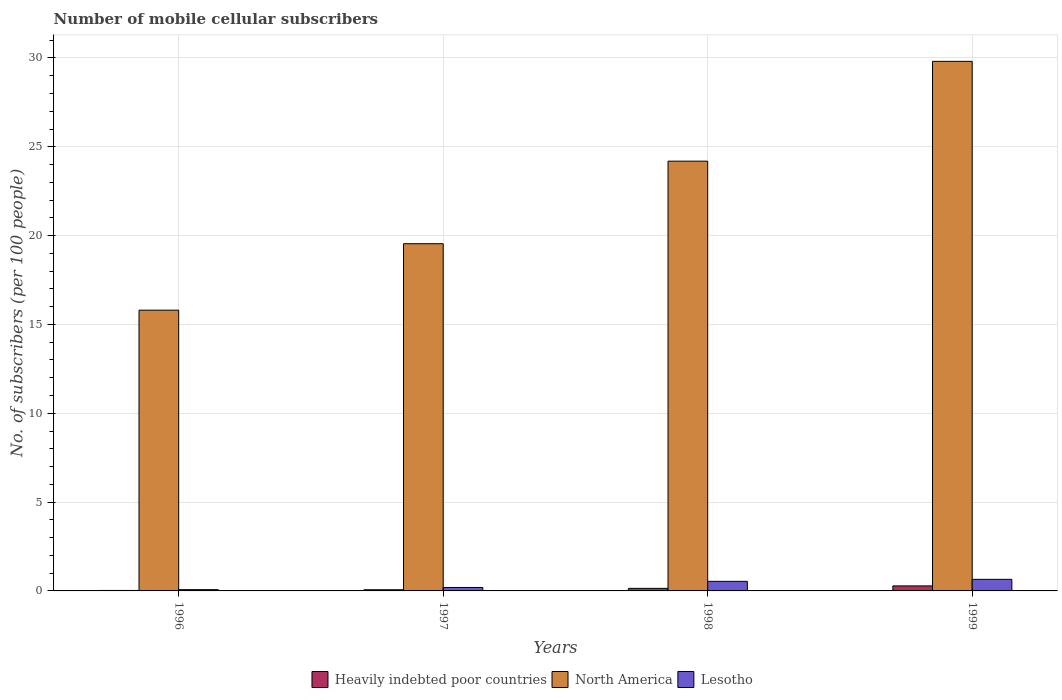How many different coloured bars are there?
Ensure brevity in your answer.  3. Are the number of bars on each tick of the X-axis equal?
Make the answer very short. Yes. How many bars are there on the 3rd tick from the left?
Give a very brief answer. 3. What is the label of the 3rd group of bars from the left?
Give a very brief answer. 1998. In how many cases, is the number of bars for a given year not equal to the number of legend labels?
Your answer should be very brief. 0. What is the number of mobile cellular subscribers in Heavily indebted poor countries in 1998?
Offer a very short reply. 0.14. Across all years, what is the maximum number of mobile cellular subscribers in North America?
Ensure brevity in your answer.  29.81. Across all years, what is the minimum number of mobile cellular subscribers in North America?
Offer a very short reply. 15.8. In which year was the number of mobile cellular subscribers in North America minimum?
Ensure brevity in your answer.  1996. What is the total number of mobile cellular subscribers in Heavily indebted poor countries in the graph?
Your answer should be very brief. 0.52. What is the difference between the number of mobile cellular subscribers in Lesotho in 1996 and that in 1999?
Your response must be concise. -0.58. What is the difference between the number of mobile cellular subscribers in Lesotho in 1999 and the number of mobile cellular subscribers in Heavily indebted poor countries in 1996?
Offer a very short reply. 0.63. What is the average number of mobile cellular subscribers in Heavily indebted poor countries per year?
Provide a succinct answer. 0.13. In the year 1999, what is the difference between the number of mobile cellular subscribers in North America and number of mobile cellular subscribers in Heavily indebted poor countries?
Ensure brevity in your answer.  29.53. In how many years, is the number of mobile cellular subscribers in Lesotho greater than 25?
Offer a very short reply. 0. What is the ratio of the number of mobile cellular subscribers in Lesotho in 1997 to that in 1999?
Your answer should be compact. 0.3. Is the difference between the number of mobile cellular subscribers in North America in 1997 and 1998 greater than the difference between the number of mobile cellular subscribers in Heavily indebted poor countries in 1997 and 1998?
Your response must be concise. No. What is the difference between the highest and the second highest number of mobile cellular subscribers in North America?
Keep it short and to the point. 5.62. What is the difference between the highest and the lowest number of mobile cellular subscribers in Lesotho?
Offer a very short reply. 0.58. In how many years, is the number of mobile cellular subscribers in Heavily indebted poor countries greater than the average number of mobile cellular subscribers in Heavily indebted poor countries taken over all years?
Offer a very short reply. 2. Is the sum of the number of mobile cellular subscribers in Heavily indebted poor countries in 1996 and 1997 greater than the maximum number of mobile cellular subscribers in Lesotho across all years?
Your answer should be very brief. No. What does the 3rd bar from the left in 1999 represents?
Make the answer very short. Lesotho. What does the 1st bar from the right in 1999 represents?
Provide a succinct answer. Lesotho. Is it the case that in every year, the sum of the number of mobile cellular subscribers in Lesotho and number of mobile cellular subscribers in Heavily indebted poor countries is greater than the number of mobile cellular subscribers in North America?
Provide a short and direct response. No. How many bars are there?
Make the answer very short. 12. Does the graph contain any zero values?
Ensure brevity in your answer.  No. Does the graph contain grids?
Offer a terse response. Yes. Where does the legend appear in the graph?
Offer a terse response. Bottom center. How many legend labels are there?
Offer a terse response. 3. What is the title of the graph?
Offer a very short reply. Number of mobile cellular subscribers. What is the label or title of the Y-axis?
Your response must be concise. No. of subscribers (per 100 people). What is the No. of subscribers (per 100 people) of Heavily indebted poor countries in 1996?
Keep it short and to the point. 0.03. What is the No. of subscribers (per 100 people) of North America in 1996?
Provide a short and direct response. 15.8. What is the No. of subscribers (per 100 people) in Lesotho in 1996?
Provide a short and direct response. 0.07. What is the No. of subscribers (per 100 people) of Heavily indebted poor countries in 1997?
Your response must be concise. 0.07. What is the No. of subscribers (per 100 people) in North America in 1997?
Provide a succinct answer. 19.54. What is the No. of subscribers (per 100 people) of Lesotho in 1997?
Provide a short and direct response. 0.19. What is the No. of subscribers (per 100 people) of Heavily indebted poor countries in 1998?
Keep it short and to the point. 0.14. What is the No. of subscribers (per 100 people) of North America in 1998?
Make the answer very short. 24.19. What is the No. of subscribers (per 100 people) in Lesotho in 1998?
Provide a short and direct response. 0.54. What is the No. of subscribers (per 100 people) of Heavily indebted poor countries in 1999?
Your answer should be compact. 0.28. What is the No. of subscribers (per 100 people) of North America in 1999?
Your answer should be very brief. 29.81. What is the No. of subscribers (per 100 people) in Lesotho in 1999?
Offer a very short reply. 0.65. Across all years, what is the maximum No. of subscribers (per 100 people) in Heavily indebted poor countries?
Give a very brief answer. 0.28. Across all years, what is the maximum No. of subscribers (per 100 people) in North America?
Give a very brief answer. 29.81. Across all years, what is the maximum No. of subscribers (per 100 people) of Lesotho?
Ensure brevity in your answer.  0.65. Across all years, what is the minimum No. of subscribers (per 100 people) in Heavily indebted poor countries?
Your answer should be compact. 0.03. Across all years, what is the minimum No. of subscribers (per 100 people) of North America?
Keep it short and to the point. 15.8. Across all years, what is the minimum No. of subscribers (per 100 people) in Lesotho?
Give a very brief answer. 0.07. What is the total No. of subscribers (per 100 people) in Heavily indebted poor countries in the graph?
Offer a very short reply. 0.52. What is the total No. of subscribers (per 100 people) of North America in the graph?
Give a very brief answer. 89.35. What is the total No. of subscribers (per 100 people) in Lesotho in the graph?
Your answer should be compact. 1.46. What is the difference between the No. of subscribers (per 100 people) of Heavily indebted poor countries in 1996 and that in 1997?
Ensure brevity in your answer.  -0.04. What is the difference between the No. of subscribers (per 100 people) in North America in 1996 and that in 1997?
Ensure brevity in your answer.  -3.74. What is the difference between the No. of subscribers (per 100 people) of Lesotho in 1996 and that in 1997?
Your response must be concise. -0.12. What is the difference between the No. of subscribers (per 100 people) of Heavily indebted poor countries in 1996 and that in 1998?
Provide a short and direct response. -0.12. What is the difference between the No. of subscribers (per 100 people) of North America in 1996 and that in 1998?
Your answer should be compact. -8.39. What is the difference between the No. of subscribers (per 100 people) of Lesotho in 1996 and that in 1998?
Ensure brevity in your answer.  -0.47. What is the difference between the No. of subscribers (per 100 people) in Heavily indebted poor countries in 1996 and that in 1999?
Provide a succinct answer. -0.26. What is the difference between the No. of subscribers (per 100 people) of North America in 1996 and that in 1999?
Keep it short and to the point. -14. What is the difference between the No. of subscribers (per 100 people) of Lesotho in 1996 and that in 1999?
Your answer should be compact. -0.58. What is the difference between the No. of subscribers (per 100 people) in Heavily indebted poor countries in 1997 and that in 1998?
Provide a short and direct response. -0.08. What is the difference between the No. of subscribers (per 100 people) of North America in 1997 and that in 1998?
Your response must be concise. -4.65. What is the difference between the No. of subscribers (per 100 people) of Lesotho in 1997 and that in 1998?
Give a very brief answer. -0.35. What is the difference between the No. of subscribers (per 100 people) in Heavily indebted poor countries in 1997 and that in 1999?
Your response must be concise. -0.22. What is the difference between the No. of subscribers (per 100 people) in North America in 1997 and that in 1999?
Provide a succinct answer. -10.26. What is the difference between the No. of subscribers (per 100 people) in Lesotho in 1997 and that in 1999?
Give a very brief answer. -0.46. What is the difference between the No. of subscribers (per 100 people) of Heavily indebted poor countries in 1998 and that in 1999?
Keep it short and to the point. -0.14. What is the difference between the No. of subscribers (per 100 people) of North America in 1998 and that in 1999?
Your response must be concise. -5.62. What is the difference between the No. of subscribers (per 100 people) in Lesotho in 1998 and that in 1999?
Provide a succinct answer. -0.11. What is the difference between the No. of subscribers (per 100 people) in Heavily indebted poor countries in 1996 and the No. of subscribers (per 100 people) in North America in 1997?
Provide a succinct answer. -19.52. What is the difference between the No. of subscribers (per 100 people) in Heavily indebted poor countries in 1996 and the No. of subscribers (per 100 people) in Lesotho in 1997?
Offer a very short reply. -0.17. What is the difference between the No. of subscribers (per 100 people) in North America in 1996 and the No. of subscribers (per 100 people) in Lesotho in 1997?
Your response must be concise. 15.61. What is the difference between the No. of subscribers (per 100 people) of Heavily indebted poor countries in 1996 and the No. of subscribers (per 100 people) of North America in 1998?
Your response must be concise. -24.16. What is the difference between the No. of subscribers (per 100 people) in Heavily indebted poor countries in 1996 and the No. of subscribers (per 100 people) in Lesotho in 1998?
Your response must be concise. -0.51. What is the difference between the No. of subscribers (per 100 people) in North America in 1996 and the No. of subscribers (per 100 people) in Lesotho in 1998?
Ensure brevity in your answer.  15.26. What is the difference between the No. of subscribers (per 100 people) of Heavily indebted poor countries in 1996 and the No. of subscribers (per 100 people) of North America in 1999?
Your response must be concise. -29.78. What is the difference between the No. of subscribers (per 100 people) of Heavily indebted poor countries in 1996 and the No. of subscribers (per 100 people) of Lesotho in 1999?
Give a very brief answer. -0.63. What is the difference between the No. of subscribers (per 100 people) in North America in 1996 and the No. of subscribers (per 100 people) in Lesotho in 1999?
Your answer should be very brief. 15.15. What is the difference between the No. of subscribers (per 100 people) of Heavily indebted poor countries in 1997 and the No. of subscribers (per 100 people) of North America in 1998?
Offer a terse response. -24.12. What is the difference between the No. of subscribers (per 100 people) of Heavily indebted poor countries in 1997 and the No. of subscribers (per 100 people) of Lesotho in 1998?
Offer a very short reply. -0.47. What is the difference between the No. of subscribers (per 100 people) of North America in 1997 and the No. of subscribers (per 100 people) of Lesotho in 1998?
Offer a terse response. 19. What is the difference between the No. of subscribers (per 100 people) in Heavily indebted poor countries in 1997 and the No. of subscribers (per 100 people) in North America in 1999?
Provide a short and direct response. -29.74. What is the difference between the No. of subscribers (per 100 people) in Heavily indebted poor countries in 1997 and the No. of subscribers (per 100 people) in Lesotho in 1999?
Make the answer very short. -0.59. What is the difference between the No. of subscribers (per 100 people) in North America in 1997 and the No. of subscribers (per 100 people) in Lesotho in 1999?
Keep it short and to the point. 18.89. What is the difference between the No. of subscribers (per 100 people) of Heavily indebted poor countries in 1998 and the No. of subscribers (per 100 people) of North America in 1999?
Your response must be concise. -29.66. What is the difference between the No. of subscribers (per 100 people) of Heavily indebted poor countries in 1998 and the No. of subscribers (per 100 people) of Lesotho in 1999?
Give a very brief answer. -0.51. What is the difference between the No. of subscribers (per 100 people) of North America in 1998 and the No. of subscribers (per 100 people) of Lesotho in 1999?
Offer a terse response. 23.54. What is the average No. of subscribers (per 100 people) in Heavily indebted poor countries per year?
Provide a short and direct response. 0.13. What is the average No. of subscribers (per 100 people) in North America per year?
Offer a very short reply. 22.34. What is the average No. of subscribers (per 100 people) in Lesotho per year?
Offer a terse response. 0.36. In the year 1996, what is the difference between the No. of subscribers (per 100 people) of Heavily indebted poor countries and No. of subscribers (per 100 people) of North America?
Make the answer very short. -15.78. In the year 1996, what is the difference between the No. of subscribers (per 100 people) of Heavily indebted poor countries and No. of subscribers (per 100 people) of Lesotho?
Your response must be concise. -0.04. In the year 1996, what is the difference between the No. of subscribers (per 100 people) of North America and No. of subscribers (per 100 people) of Lesotho?
Provide a succinct answer. 15.73. In the year 1997, what is the difference between the No. of subscribers (per 100 people) in Heavily indebted poor countries and No. of subscribers (per 100 people) in North America?
Make the answer very short. -19.48. In the year 1997, what is the difference between the No. of subscribers (per 100 people) in Heavily indebted poor countries and No. of subscribers (per 100 people) in Lesotho?
Provide a succinct answer. -0.13. In the year 1997, what is the difference between the No. of subscribers (per 100 people) of North America and No. of subscribers (per 100 people) of Lesotho?
Give a very brief answer. 19.35. In the year 1998, what is the difference between the No. of subscribers (per 100 people) in Heavily indebted poor countries and No. of subscribers (per 100 people) in North America?
Your response must be concise. -24.05. In the year 1998, what is the difference between the No. of subscribers (per 100 people) of Heavily indebted poor countries and No. of subscribers (per 100 people) of Lesotho?
Provide a succinct answer. -0.4. In the year 1998, what is the difference between the No. of subscribers (per 100 people) in North America and No. of subscribers (per 100 people) in Lesotho?
Keep it short and to the point. 23.65. In the year 1999, what is the difference between the No. of subscribers (per 100 people) of Heavily indebted poor countries and No. of subscribers (per 100 people) of North America?
Your response must be concise. -29.53. In the year 1999, what is the difference between the No. of subscribers (per 100 people) in Heavily indebted poor countries and No. of subscribers (per 100 people) in Lesotho?
Give a very brief answer. -0.37. In the year 1999, what is the difference between the No. of subscribers (per 100 people) of North America and No. of subscribers (per 100 people) of Lesotho?
Keep it short and to the point. 29.16. What is the ratio of the No. of subscribers (per 100 people) in Heavily indebted poor countries in 1996 to that in 1997?
Your answer should be compact. 0.41. What is the ratio of the No. of subscribers (per 100 people) in North America in 1996 to that in 1997?
Provide a succinct answer. 0.81. What is the ratio of the No. of subscribers (per 100 people) of Lesotho in 1996 to that in 1997?
Offer a terse response. 0.37. What is the ratio of the No. of subscribers (per 100 people) of Heavily indebted poor countries in 1996 to that in 1998?
Your response must be concise. 0.19. What is the ratio of the No. of subscribers (per 100 people) in North America in 1996 to that in 1998?
Ensure brevity in your answer.  0.65. What is the ratio of the No. of subscribers (per 100 people) in Lesotho in 1996 to that in 1998?
Offer a terse response. 0.13. What is the ratio of the No. of subscribers (per 100 people) of Heavily indebted poor countries in 1996 to that in 1999?
Give a very brief answer. 0.1. What is the ratio of the No. of subscribers (per 100 people) of North America in 1996 to that in 1999?
Provide a succinct answer. 0.53. What is the ratio of the No. of subscribers (per 100 people) of Lesotho in 1996 to that in 1999?
Offer a terse response. 0.11. What is the ratio of the No. of subscribers (per 100 people) of Heavily indebted poor countries in 1997 to that in 1998?
Your answer should be very brief. 0.46. What is the ratio of the No. of subscribers (per 100 people) in North America in 1997 to that in 1998?
Provide a short and direct response. 0.81. What is the ratio of the No. of subscribers (per 100 people) in Lesotho in 1997 to that in 1998?
Ensure brevity in your answer.  0.36. What is the ratio of the No. of subscribers (per 100 people) in Heavily indebted poor countries in 1997 to that in 1999?
Give a very brief answer. 0.23. What is the ratio of the No. of subscribers (per 100 people) of North America in 1997 to that in 1999?
Offer a terse response. 0.66. What is the ratio of the No. of subscribers (per 100 people) of Lesotho in 1997 to that in 1999?
Offer a terse response. 0.3. What is the ratio of the No. of subscribers (per 100 people) of Heavily indebted poor countries in 1998 to that in 1999?
Keep it short and to the point. 0.51. What is the ratio of the No. of subscribers (per 100 people) in North America in 1998 to that in 1999?
Provide a succinct answer. 0.81. What is the ratio of the No. of subscribers (per 100 people) of Lesotho in 1998 to that in 1999?
Offer a very short reply. 0.83. What is the difference between the highest and the second highest No. of subscribers (per 100 people) in Heavily indebted poor countries?
Provide a short and direct response. 0.14. What is the difference between the highest and the second highest No. of subscribers (per 100 people) in North America?
Offer a very short reply. 5.62. What is the difference between the highest and the second highest No. of subscribers (per 100 people) in Lesotho?
Provide a short and direct response. 0.11. What is the difference between the highest and the lowest No. of subscribers (per 100 people) in Heavily indebted poor countries?
Your response must be concise. 0.26. What is the difference between the highest and the lowest No. of subscribers (per 100 people) of North America?
Ensure brevity in your answer.  14. What is the difference between the highest and the lowest No. of subscribers (per 100 people) in Lesotho?
Offer a very short reply. 0.58. 